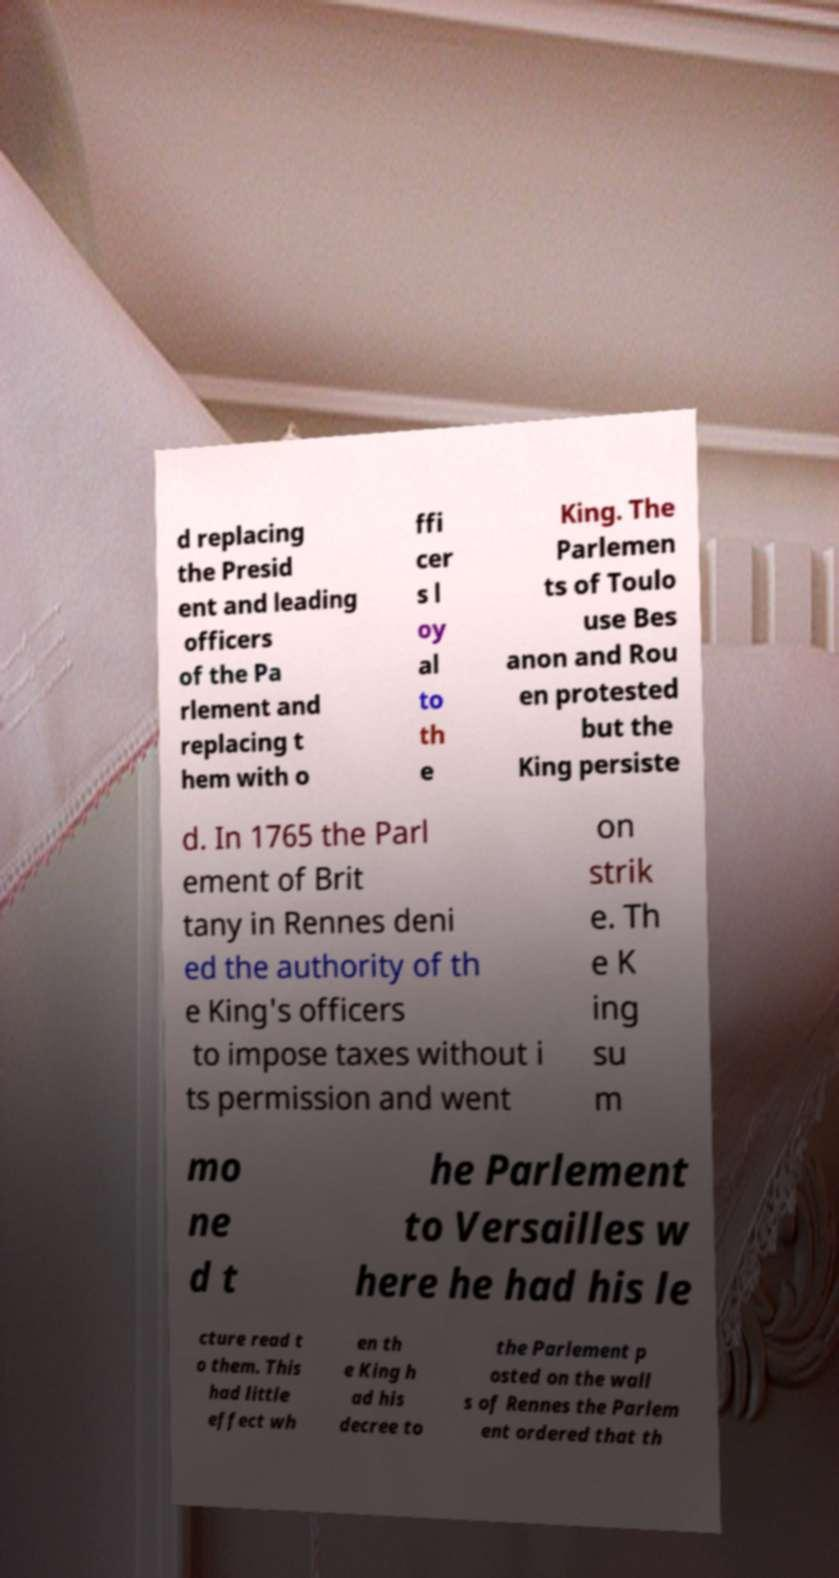Can you read and provide the text displayed in the image?This photo seems to have some interesting text. Can you extract and type it out for me? d replacing the Presid ent and leading officers of the Pa rlement and replacing t hem with o ffi cer s l oy al to th e King. The Parlemen ts of Toulo use Bes anon and Rou en protested but the King persiste d. In 1765 the Parl ement of Brit tany in Rennes deni ed the authority of th e King's officers to impose taxes without i ts permission and went on strik e. Th e K ing su m mo ne d t he Parlement to Versailles w here he had his le cture read t o them. This had little effect wh en th e King h ad his decree to the Parlement p osted on the wall s of Rennes the Parlem ent ordered that th 